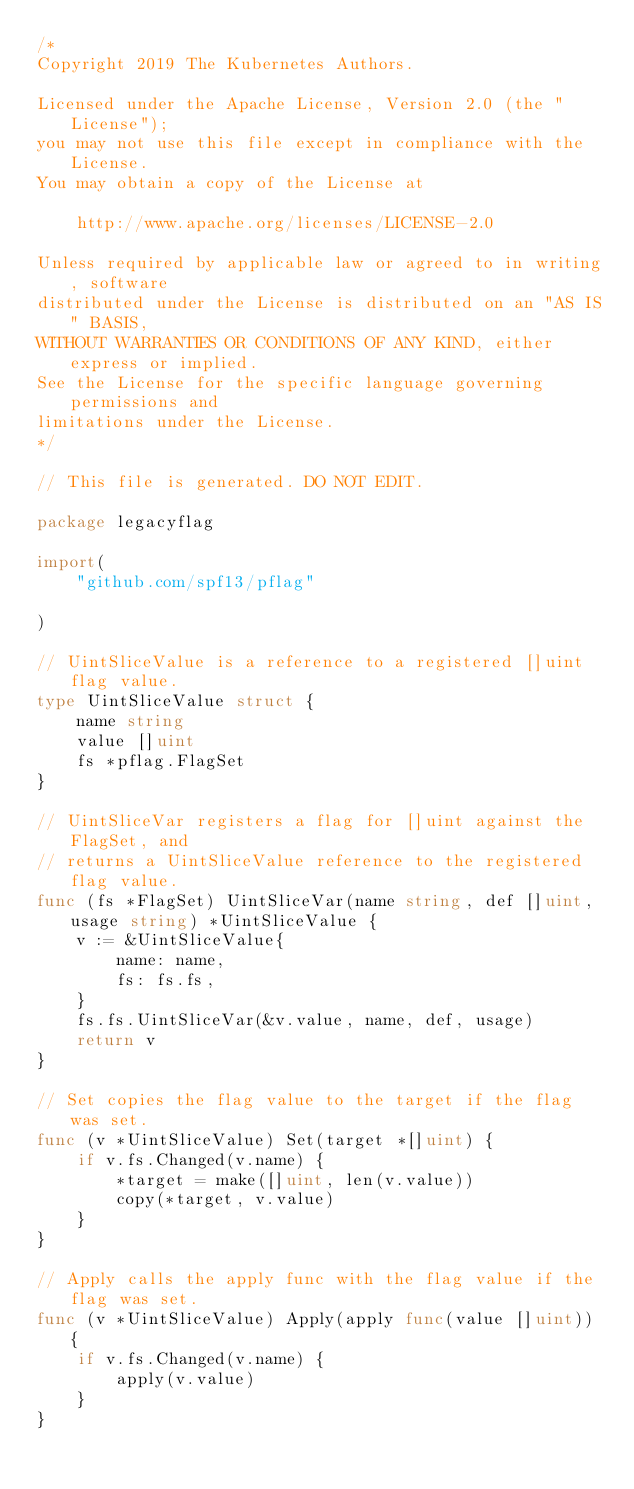<code> <loc_0><loc_0><loc_500><loc_500><_Go_>/*
Copyright 2019 The Kubernetes Authors.

Licensed under the Apache License, Version 2.0 (the "License");
you may not use this file except in compliance with the License.
You may obtain a copy of the License at

	http://www.apache.org/licenses/LICENSE-2.0

Unless required by applicable law or agreed to in writing, software
distributed under the License is distributed on an "AS IS" BASIS,
WITHOUT WARRANTIES OR CONDITIONS OF ANY KIND, either express or implied.
See the License for the specific language governing permissions and
limitations under the License.
*/

// This file is generated. DO NOT EDIT.

package legacyflag

import(
	"github.com/spf13/pflag"
	
)

// UintSliceValue is a reference to a registered []uint flag value.
type UintSliceValue struct {
	name string
	value []uint
	fs *pflag.FlagSet
}

// UintSliceVar registers a flag for []uint against the FlagSet, and
// returns a UintSliceValue reference to the registered flag value.
func (fs *FlagSet) UintSliceVar(name string, def []uint, usage string) *UintSliceValue {
	v := &UintSliceValue{
		name: name,
		fs: fs.fs,
	}
	fs.fs.UintSliceVar(&v.value, name, def, usage)
	return v
}

// Set copies the flag value to the target if the flag was set.
func (v *UintSliceValue) Set(target *[]uint) {
	if v.fs.Changed(v.name) {
		*target = make([]uint, len(v.value))
		copy(*target, v.value)
	}
}

// Apply calls the apply func with the flag value if the flag was set.
func (v *UintSliceValue) Apply(apply func(value []uint)) {
	if v.fs.Changed(v.name) {
		apply(v.value)
	}
}
</code> 